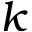<formula> <loc_0><loc_0><loc_500><loc_500>k</formula> 